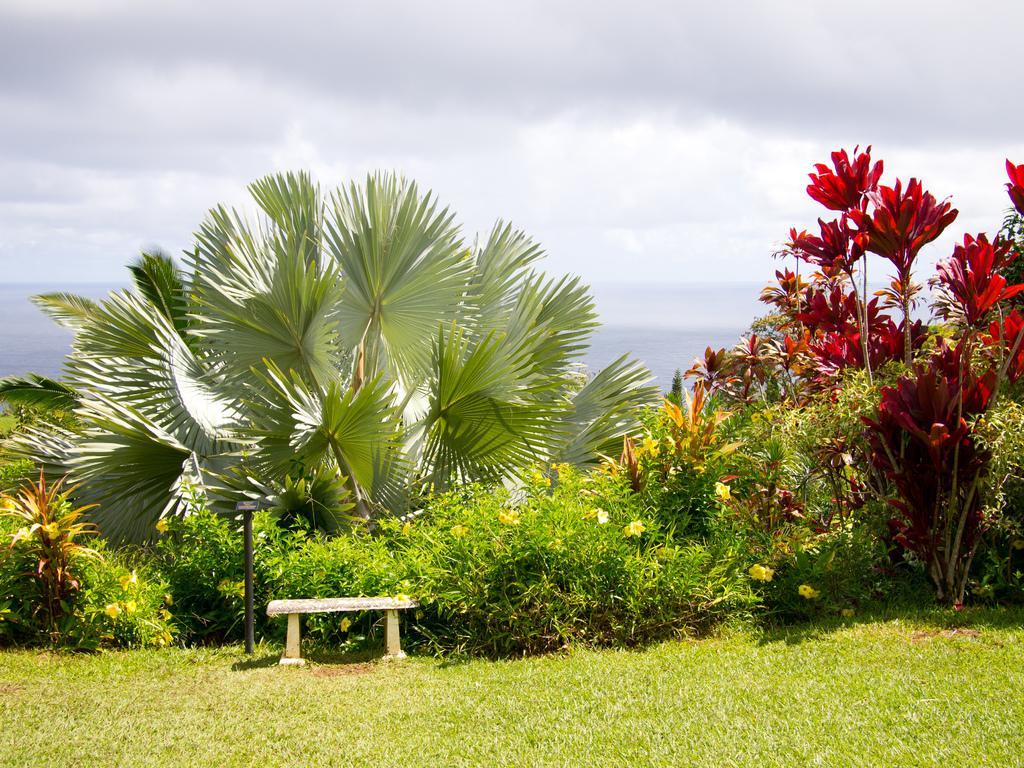Can you describe this image briefly? In the center of the image we can see plants, grass, one pole, one bench and flowers, which are in yellow color. In the background we can see the sky and clouds. 